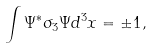<formula> <loc_0><loc_0><loc_500><loc_500>\int \Psi ^ { * } \sigma _ { 3 } \Psi d ^ { 3 } x = \pm 1 ,</formula> 